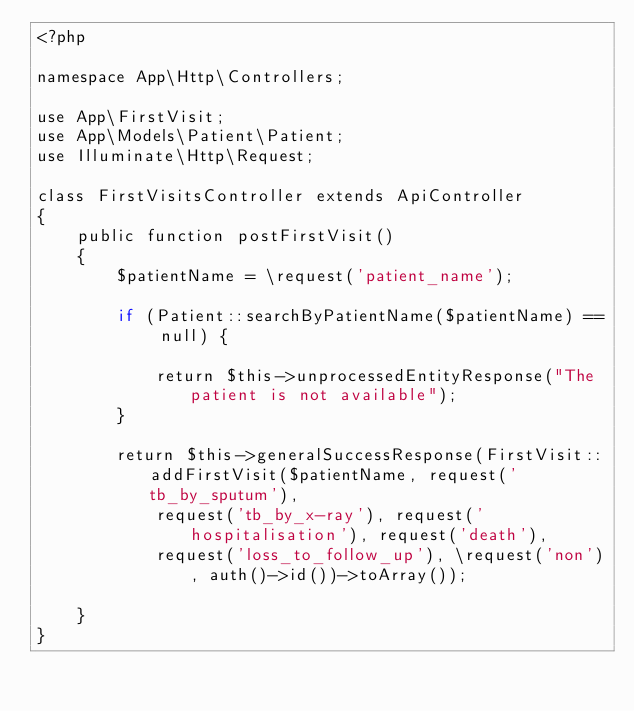Convert code to text. <code><loc_0><loc_0><loc_500><loc_500><_PHP_><?php

namespace App\Http\Controllers;

use App\FirstVisit;
use App\Models\Patient\Patient;
use Illuminate\Http\Request;

class FirstVisitsController extends ApiController
{
    public function postFirstVisit()
    {
        $patientName = \request('patient_name');

        if (Patient::searchByPatientName($patientName) == null) {

            return $this->unprocessedEntityResponse("The patient is not available");
        }

        return $this->generalSuccessResponse(FirstVisit::addFirstVisit($patientName, request('tb_by_sputum'),
            request('tb_by_x-ray'), request('hospitalisation'), request('death'),
            request('loss_to_follow_up'), \request('non'), auth()->id())->toArray());

    }
}
</code> 